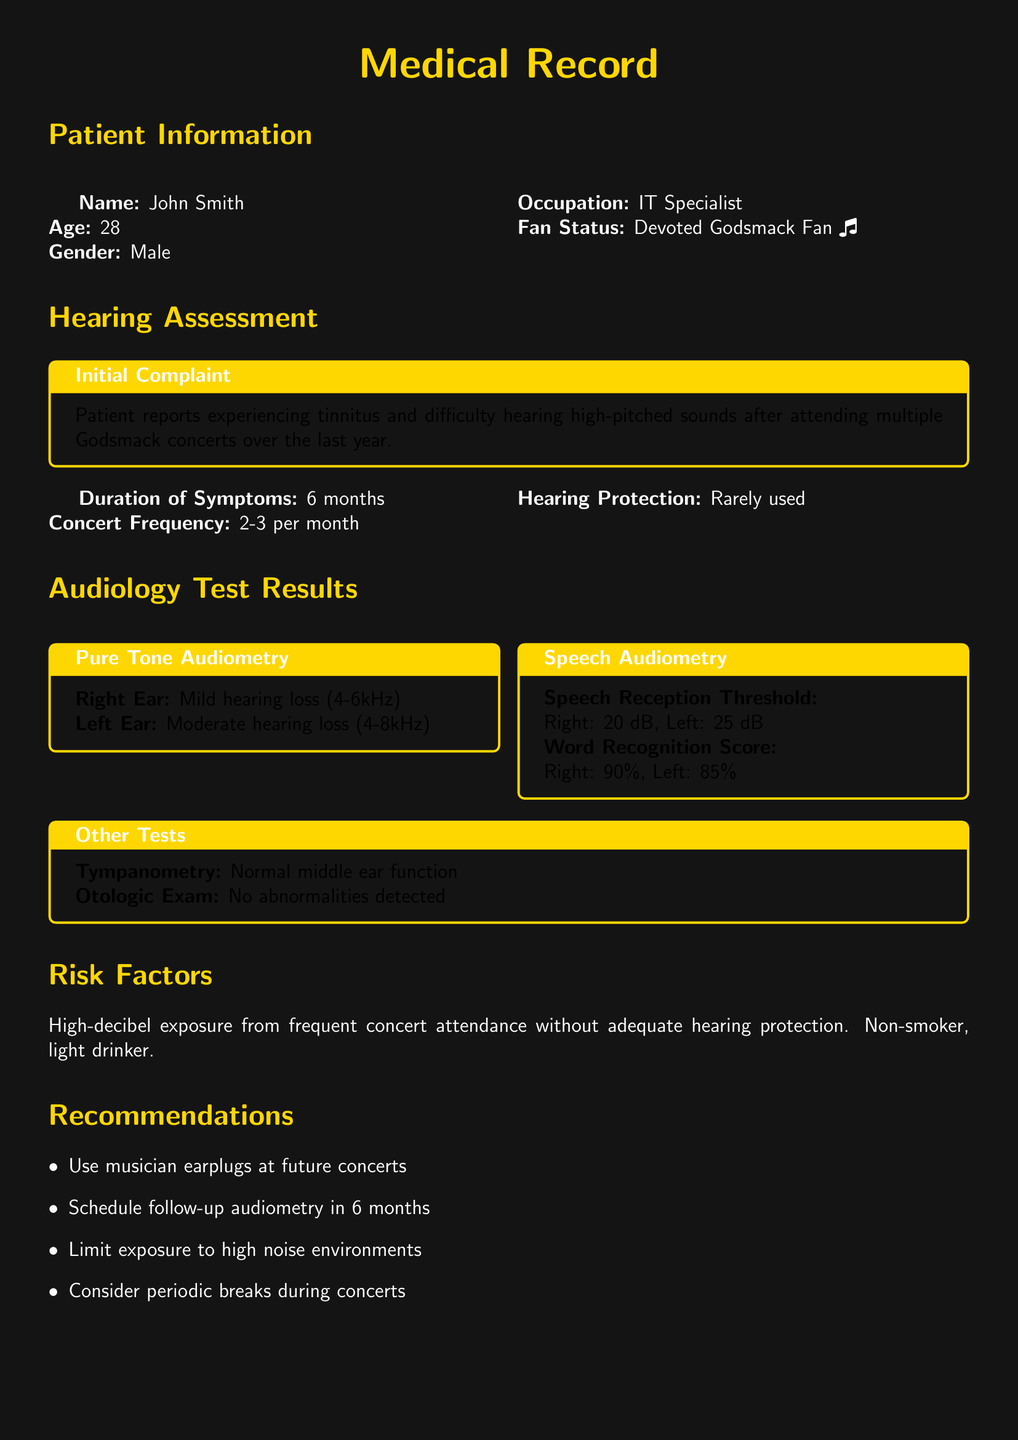What is the patient's name? The patient's name is listed in the Patient Information section of the document.
Answer: John Smith What is the patient's age? The age of the patient is provided in the Patient Information section.
Answer: 28 How long has the patient experienced symptoms? The duration of symptoms is mentioned in the Hearing Assessment section.
Answer: 6 months What is the patient's word recognition score for the left ear? The word recognition score for the left ear can be found in the Speech Audiometry test results.
Answer: 85% What are the recommendations for the patient? The recommendations are provided in a list format in the Recommendations section.
Answer: Use musician earplugs at future concerts What type of hearing loss does the patient have in the right ear? The specific type of hearing loss in the right ear is detailed in the Pure Tone Audiometry results.
Answer: Mild hearing loss What did the doctor note about the patient's condition? The doctor's notes summarize the overall assessment and recommendations in the Doctor's Notes section.
Answer: Damage from prolonged exposure to high-decibel environments What was the frequency of concert attendance by the patient? The concert frequency is mentioned in the Hearing Assessment section.
Answer: 2-3 per month What was the tympanometry result? The results of the tympanometry test are specified in the Other Tests section.
Answer: Normal middle ear function 